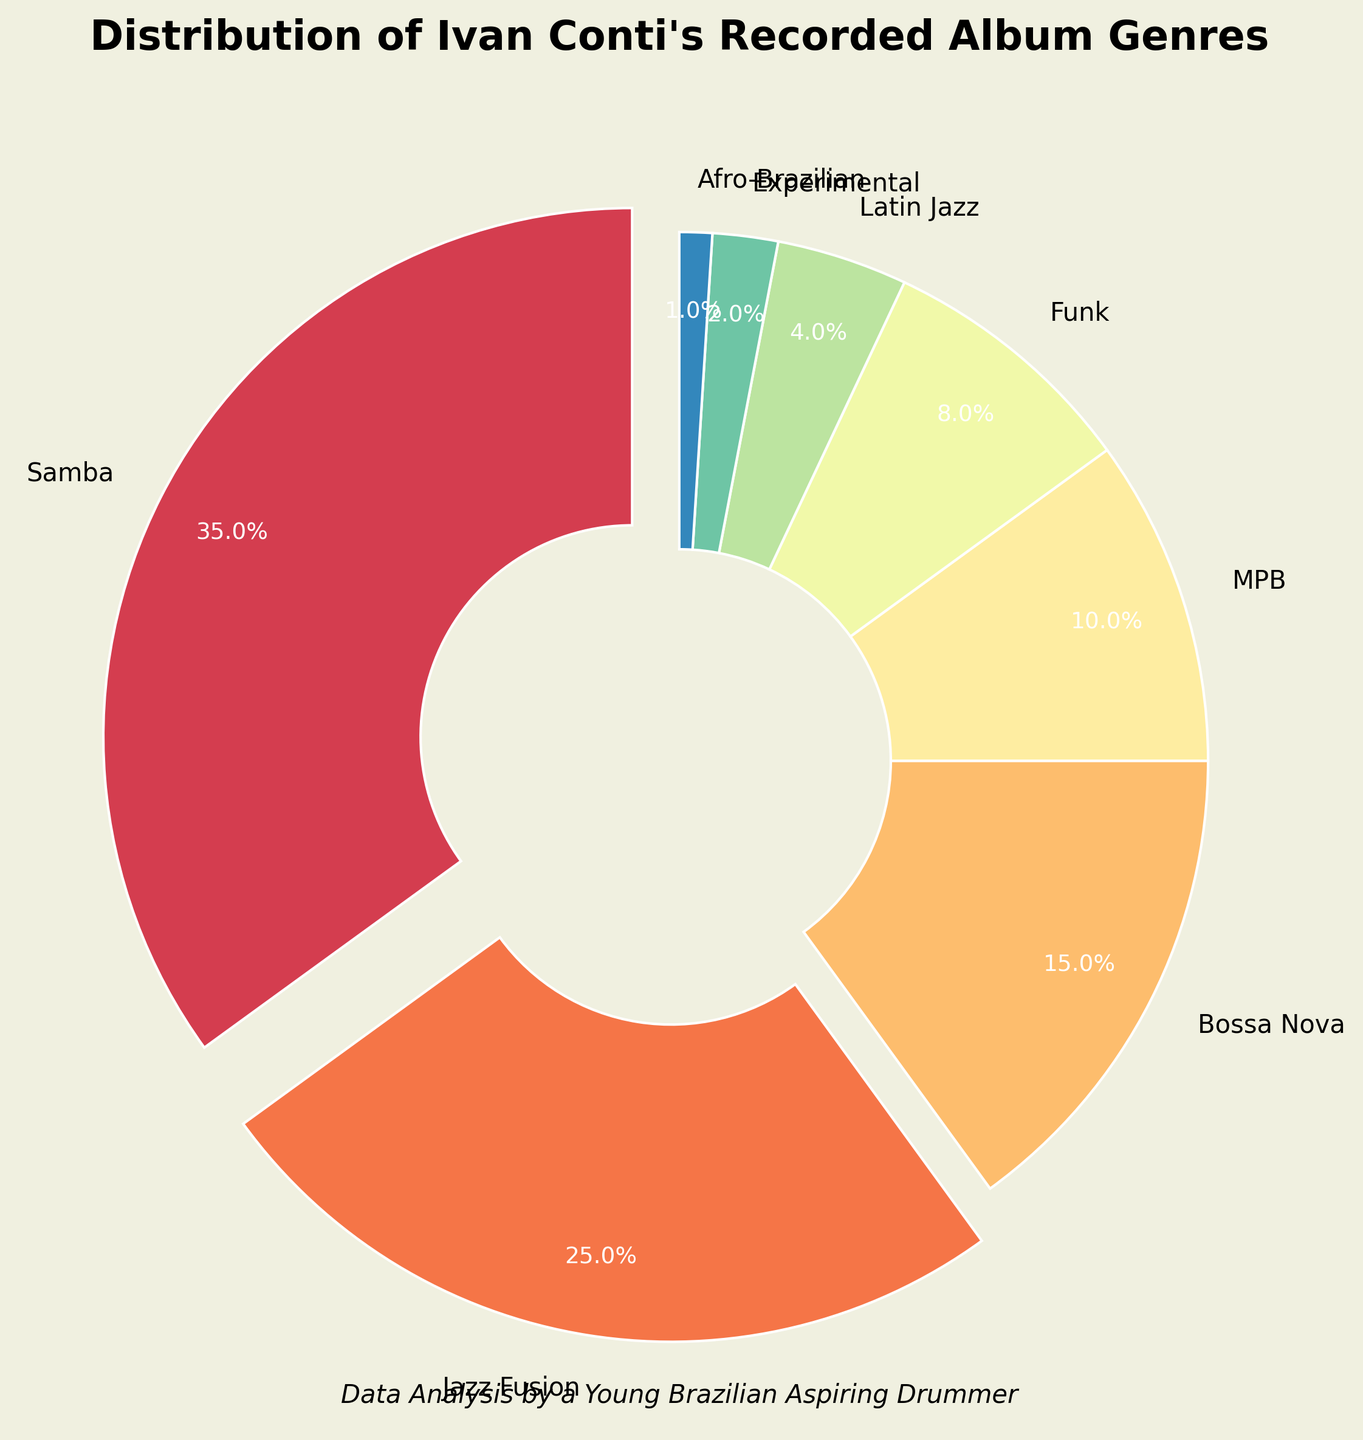Which genre represents the largest portion of Ivan Conti's recorded albums? The genre with the largest segment in the pie chart represents the largest portion. From the chart, Samba has the largest slice.
Answer: Samba What is the total percentage of Jazz Fusion and Bossa Nova combined? To find the combined percentage of Jazz Fusion and Bossa Nova, add their individual percentages: 25% (Jazz Fusion) + 15% (Bossa Nova) = 40%.
Answer: 40% How much larger is the percentage of Samba albums compared to MPB albums? The difference in percentage is calculated by subtracting the MPB percentage from the Samba percentage: 35% (Samba) - 10% (MPB) = 25%.
Answer: 25% Which album genre has the smallest representation in Ivan Conti's recordings? The smallest segment in the pie chart represents the genre with the smallest percentage. From the chart, Afro-Brazilian has the smallest slice.
Answer: Afro-Brazilian What is the combined percentage of Ivan Conti's albums in genres containing the word "Jazz"? To find this, sum the percentages of 'Jazz Fusion' and 'Latin Jazz': 25% (Jazz Fusion) + 4% (Latin Jazz) = 29%.
Answer: 29% How many genres have a representation of less than 10%? Count the number of segments in the pie chart with percentages less than 10%: Funk (8%), Latin Jazz (4%), Experimental (2%), Afro-Brazilian (1%) = 4 genres.
Answer: 4 Compare the visual size of the Samba and Jazz Fusion segments. Which one is visually larger? By observing the pie chart, the Samba segment takes up a larger portion of the pie compared to the Jazz Fusion segment.
Answer: Samba Is the percentage of Bossa Nova albums greater than twice the percentage of Experimental albums? Compare the percentage of Bossa Nova (15%) with twice the percentage of Experimental (2%) which is 2 * 2% = 4%. Since 15% is indeed greater than 4%, yes, it is greater.
Answer: Yes 